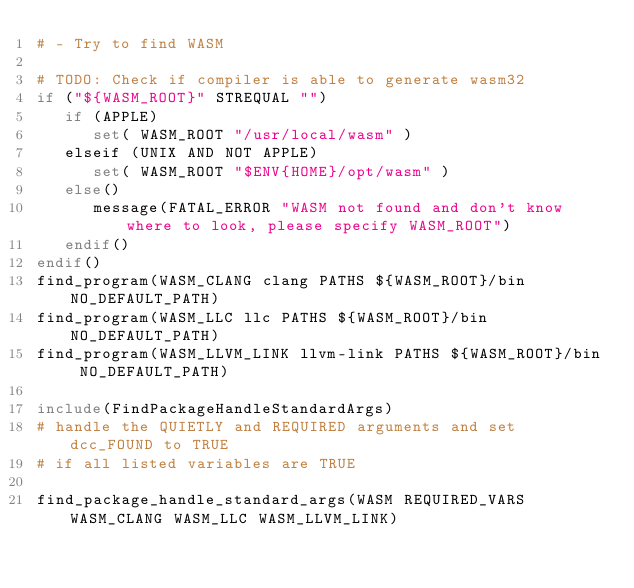<code> <loc_0><loc_0><loc_500><loc_500><_CMake_># - Try to find WASM

# TODO: Check if compiler is able to generate wasm32
if ("${WASM_ROOT}" STREQUAL "")
   if (APPLE)
      set( WASM_ROOT "/usr/local/wasm" )
   elseif (UNIX AND NOT APPLE)
      set( WASM_ROOT "$ENV{HOME}/opt/wasm" )
   else()
      message(FATAL_ERROR "WASM not found and don't know where to look, please specify WASM_ROOT")
   endif()
endif()
find_program(WASM_CLANG clang PATHS ${WASM_ROOT}/bin NO_DEFAULT_PATH)
find_program(WASM_LLC llc PATHS ${WASM_ROOT}/bin NO_DEFAULT_PATH)
find_program(WASM_LLVM_LINK llvm-link PATHS ${WASM_ROOT}/bin NO_DEFAULT_PATH)

include(FindPackageHandleStandardArgs)
# handle the QUIETLY and REQUIRED arguments and set dcc_FOUND to TRUE
# if all listed variables are TRUE

find_package_handle_standard_args(WASM REQUIRED_VARS WASM_CLANG WASM_LLC WASM_LLVM_LINK)

</code> 